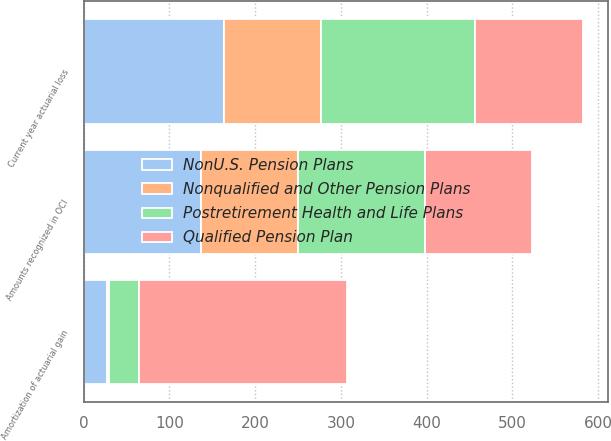Convert chart. <chart><loc_0><loc_0><loc_500><loc_500><stacked_bar_chart><ecel><fcel>Current year actuarial loss<fcel>Amortization of actuarial gain<fcel>Amounts recognized in OCI<nl><fcel>Qualified Pension Plan<fcel>125<fcel>242<fcel>125<nl><fcel>Nonqualified and Other Pension Plans<fcel>113<fcel>2<fcel>113<nl><fcel>NonU.S. Pension Plans<fcel>164<fcel>27<fcel>137<nl><fcel>Postretirement Health and Life Plans<fcel>180<fcel>36<fcel>148<nl></chart> 